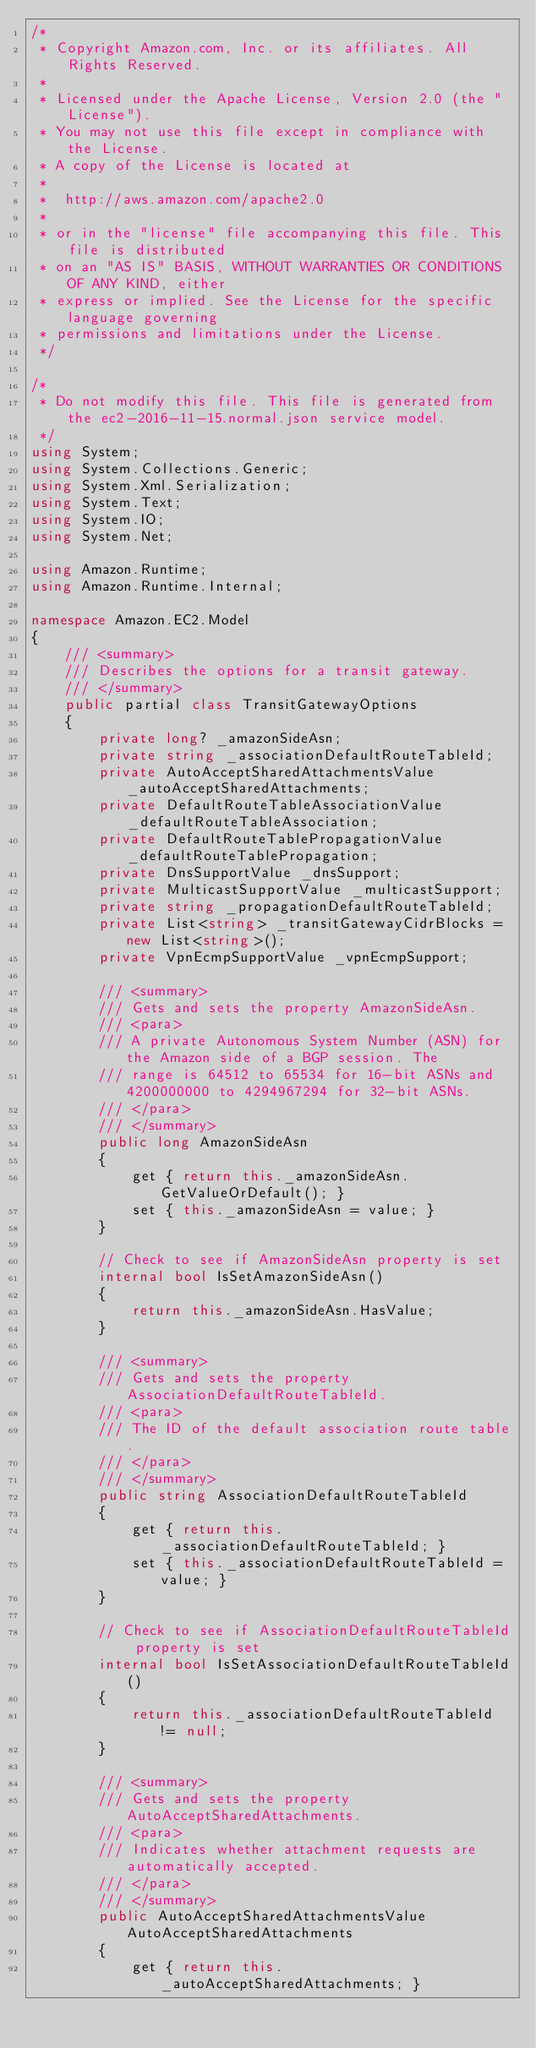Convert code to text. <code><loc_0><loc_0><loc_500><loc_500><_C#_>/*
 * Copyright Amazon.com, Inc. or its affiliates. All Rights Reserved.
 * 
 * Licensed under the Apache License, Version 2.0 (the "License").
 * You may not use this file except in compliance with the License.
 * A copy of the License is located at
 * 
 *  http://aws.amazon.com/apache2.0
 * 
 * or in the "license" file accompanying this file. This file is distributed
 * on an "AS IS" BASIS, WITHOUT WARRANTIES OR CONDITIONS OF ANY KIND, either
 * express or implied. See the License for the specific language governing
 * permissions and limitations under the License.
 */

/*
 * Do not modify this file. This file is generated from the ec2-2016-11-15.normal.json service model.
 */
using System;
using System.Collections.Generic;
using System.Xml.Serialization;
using System.Text;
using System.IO;
using System.Net;

using Amazon.Runtime;
using Amazon.Runtime.Internal;

namespace Amazon.EC2.Model
{
    /// <summary>
    /// Describes the options for a transit gateway.
    /// </summary>
    public partial class TransitGatewayOptions
    {
        private long? _amazonSideAsn;
        private string _associationDefaultRouteTableId;
        private AutoAcceptSharedAttachmentsValue _autoAcceptSharedAttachments;
        private DefaultRouteTableAssociationValue _defaultRouteTableAssociation;
        private DefaultRouteTablePropagationValue _defaultRouteTablePropagation;
        private DnsSupportValue _dnsSupport;
        private MulticastSupportValue _multicastSupport;
        private string _propagationDefaultRouteTableId;
        private List<string> _transitGatewayCidrBlocks = new List<string>();
        private VpnEcmpSupportValue _vpnEcmpSupport;

        /// <summary>
        /// Gets and sets the property AmazonSideAsn. 
        /// <para>
        /// A private Autonomous System Number (ASN) for the Amazon side of a BGP session. The
        /// range is 64512 to 65534 for 16-bit ASNs and 4200000000 to 4294967294 for 32-bit ASNs.
        /// </para>
        /// </summary>
        public long AmazonSideAsn
        {
            get { return this._amazonSideAsn.GetValueOrDefault(); }
            set { this._amazonSideAsn = value; }
        }

        // Check to see if AmazonSideAsn property is set
        internal bool IsSetAmazonSideAsn()
        {
            return this._amazonSideAsn.HasValue; 
        }

        /// <summary>
        /// Gets and sets the property AssociationDefaultRouteTableId. 
        /// <para>
        /// The ID of the default association route table.
        /// </para>
        /// </summary>
        public string AssociationDefaultRouteTableId
        {
            get { return this._associationDefaultRouteTableId; }
            set { this._associationDefaultRouteTableId = value; }
        }

        // Check to see if AssociationDefaultRouteTableId property is set
        internal bool IsSetAssociationDefaultRouteTableId()
        {
            return this._associationDefaultRouteTableId != null;
        }

        /// <summary>
        /// Gets and sets the property AutoAcceptSharedAttachments. 
        /// <para>
        /// Indicates whether attachment requests are automatically accepted.
        /// </para>
        /// </summary>
        public AutoAcceptSharedAttachmentsValue AutoAcceptSharedAttachments
        {
            get { return this._autoAcceptSharedAttachments; }</code> 